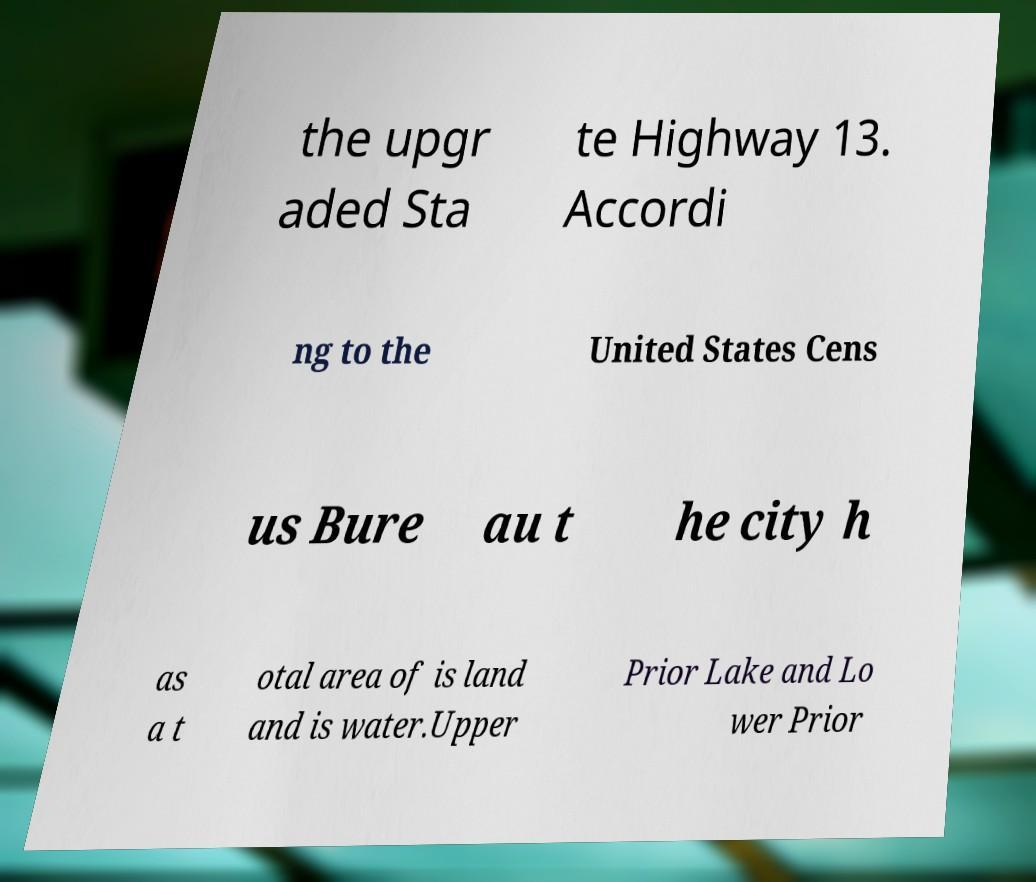Please read and relay the text visible in this image. What does it say? the upgr aded Sta te Highway 13. Accordi ng to the United States Cens us Bure au t he city h as a t otal area of is land and is water.Upper Prior Lake and Lo wer Prior 